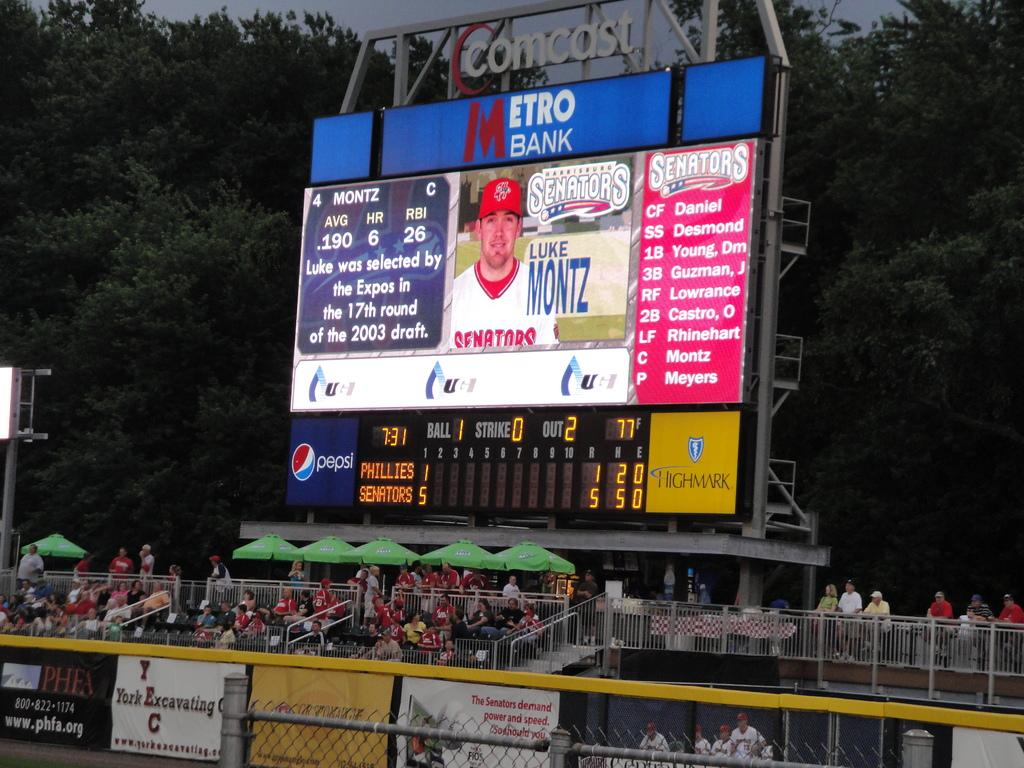<image>
Present a compact description of the photo's key features. Comcast scoreboard sponsored by Metro Bank and Pepsi displaying the stats for Luke Montz 